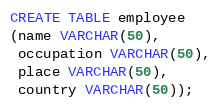<code> <loc_0><loc_0><loc_500><loc_500><_SQL_>CREATE TABLE employee
(name VARCHAR(50),
 occupation VARCHAR(50),
 place VARCHAR(50),
 country VARCHAR(50));
</code> 